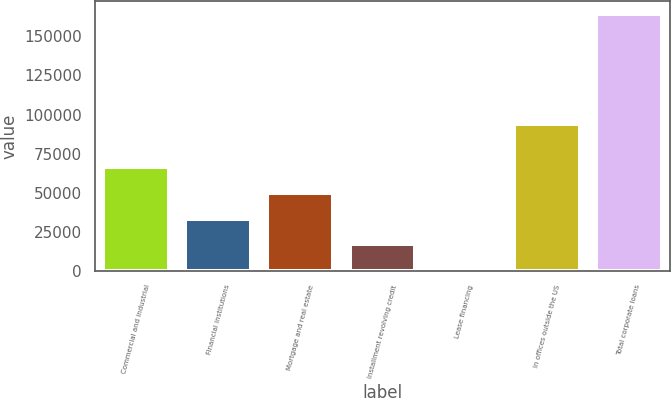<chart> <loc_0><loc_0><loc_500><loc_500><bar_chart><fcel>Commercial and industrial<fcel>Financial institutions<fcel>Mortgage and real estate<fcel>Installment revolving credit<fcel>Lease financing<fcel>In offices outside the US<fcel>Total corporate loans<nl><fcel>66169<fcel>33419<fcel>49794<fcel>17044<fcel>669<fcel>93993<fcel>164419<nl></chart> 